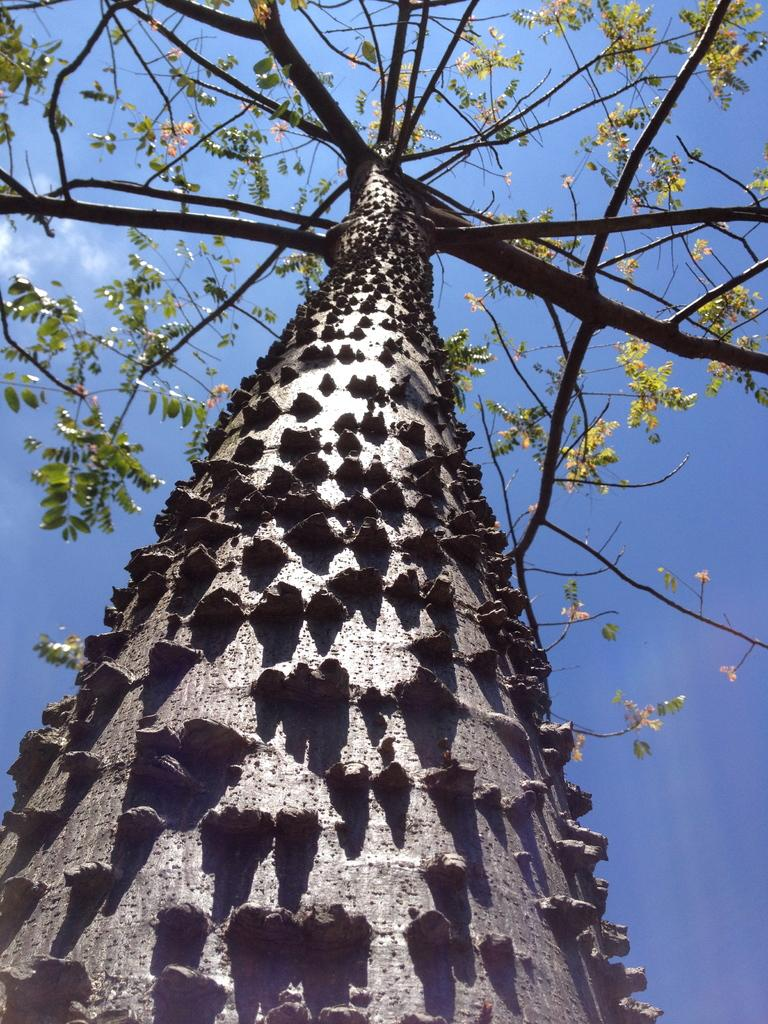What type of plant can be seen in the image? There is a tree in the image. What is the color of the tree? The tree is green in color. What can be seen in the background of the image? The sky is visible in the background of the image. What colors are present in the sky? The sky is blue and white in color. What type of health benefits can be gained from the sponge in the image? There is no sponge present in the image, so it is not possible to discuss any health benefits related to it. 